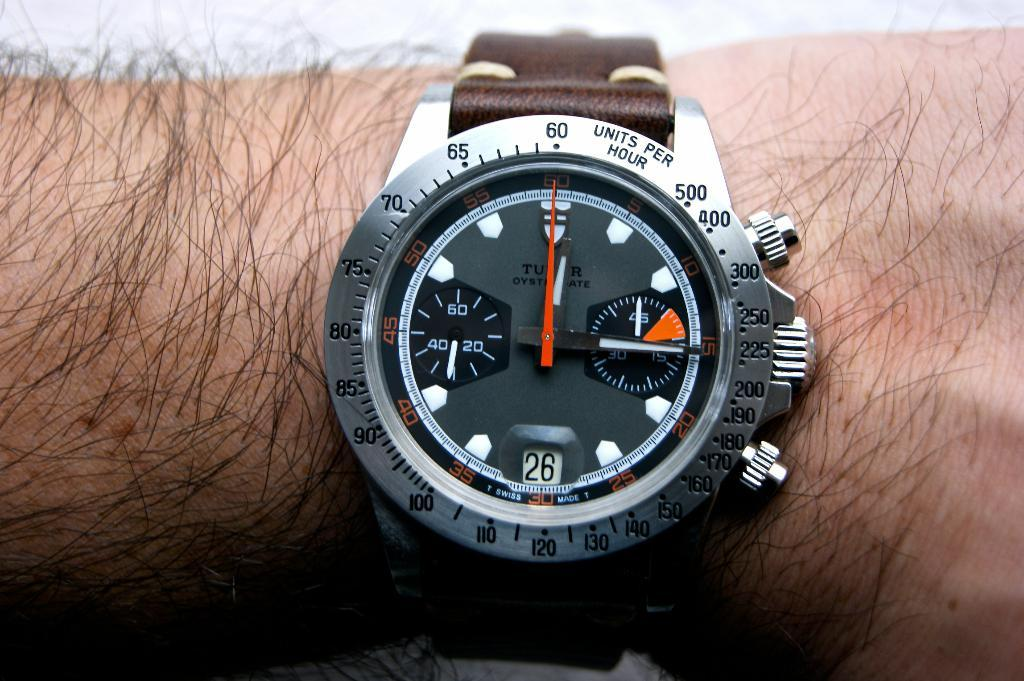<image>
Create a compact narrative representing the image presented. Someone is wearing a watch that has a band around the face that says "units per hour" on it. 